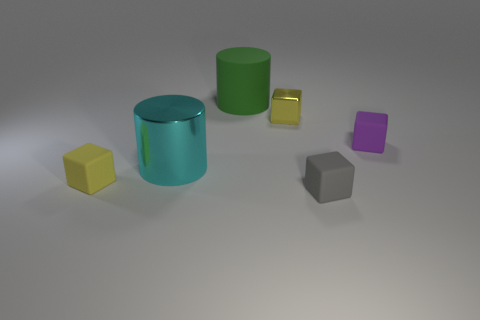There is a tiny rubber thing to the right of the tiny gray object; is it the same shape as the matte object that is to the left of the green matte cylinder?
Make the answer very short. Yes. Are the small block that is to the left of the green cylinder and the tiny yellow object that is on the right side of the big metallic thing made of the same material?
Make the answer very short. No. There is a yellow rubber object that is in front of the cube that is right of the gray object; what shape is it?
Offer a very short reply. Cube. Is there anything else that is the same color as the shiny cylinder?
Your response must be concise. No. Is there a small rubber thing behind the tiny yellow thing left of the large green object that is on the left side of the tiny metallic cube?
Your answer should be very brief. Yes. There is a tiny rubber cube that is on the left side of the gray rubber block; is its color the same as the metallic cube that is behind the yellow matte thing?
Provide a short and direct response. Yes. There is a gray block that is the same size as the purple rubber thing; what is it made of?
Provide a succinct answer. Rubber. There is a rubber cube that is behind the tiny thing left of the large matte object on the right side of the cyan object; what size is it?
Make the answer very short. Small. What number of other objects are there of the same material as the cyan cylinder?
Ensure brevity in your answer.  1. There is a yellow thing right of the big green cylinder; what size is it?
Ensure brevity in your answer.  Small. 